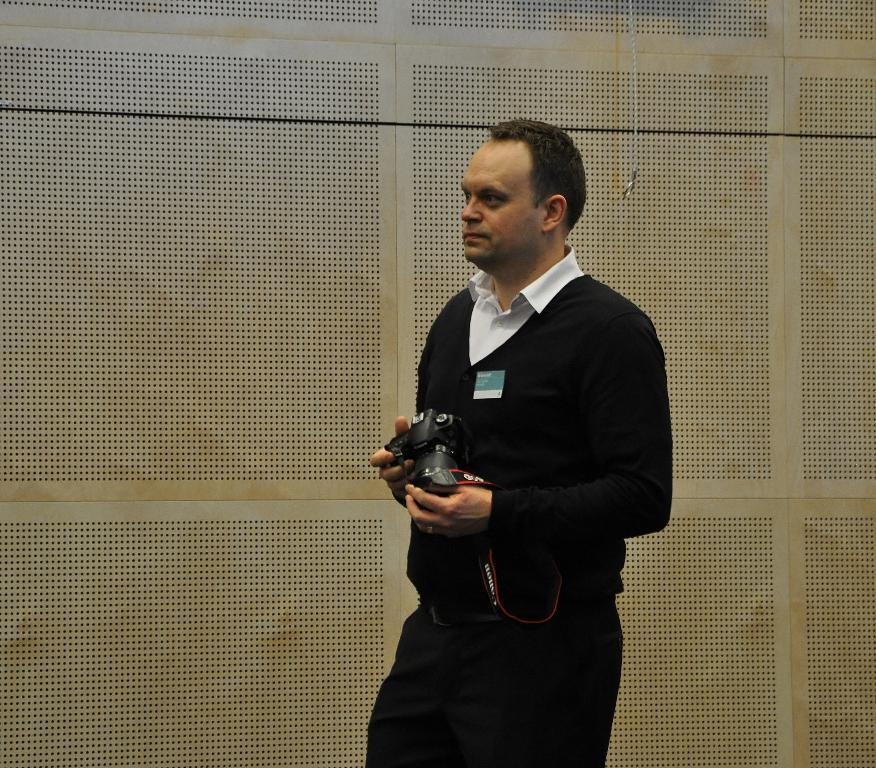What is the main subject of the image? There is a person standing in the image. What is the person holding in their hand? The person is holding a camera in their hand. Can you describe the background of the image? The background wall resembles a fence. Where was the image taken? The image was taken inside a room. What type of punishment is the person receiving in the image? There is no indication of punishment in the image; the person is simply standing and holding a camera. What kind of jelly can be seen on the person's clothing in the image? There is no jelly present on the person's clothing in the image. 